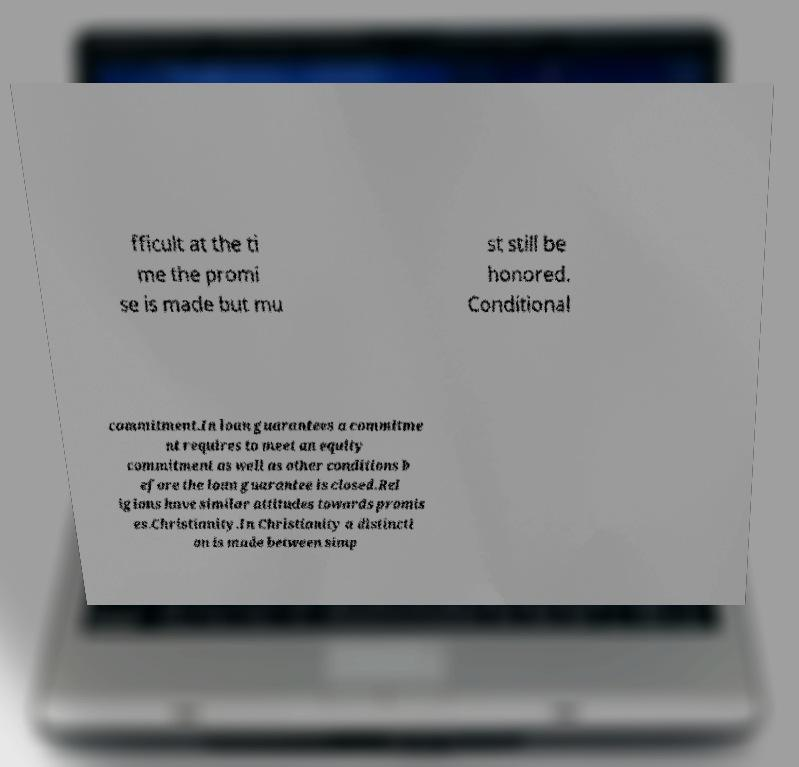For documentation purposes, I need the text within this image transcribed. Could you provide that? fficult at the ti me the promi se is made but mu st still be honored. Conditional commitment.In loan guarantees a commitme nt requires to meet an equity commitment as well as other conditions b efore the loan guarantee is closed.Rel igions have similar attitudes towards promis es.Christianity.In Christianity a distincti on is made between simp 